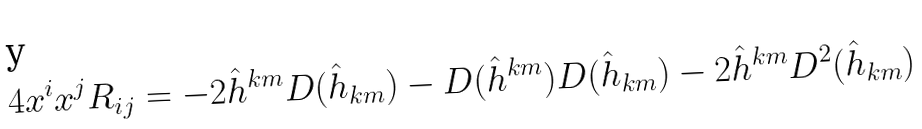Convert formula to latex. <formula><loc_0><loc_0><loc_500><loc_500>4 x ^ { i } x ^ { j } R _ { i j } = - 2 \hat { h } ^ { k m } D ( \hat { h } _ { k m } ) - D ( \hat { h } ^ { k m } ) D ( \hat { h } _ { k m } ) - 2 \hat { h } ^ { k m } D ^ { 2 } ( \hat { h } _ { k m } )</formula> 